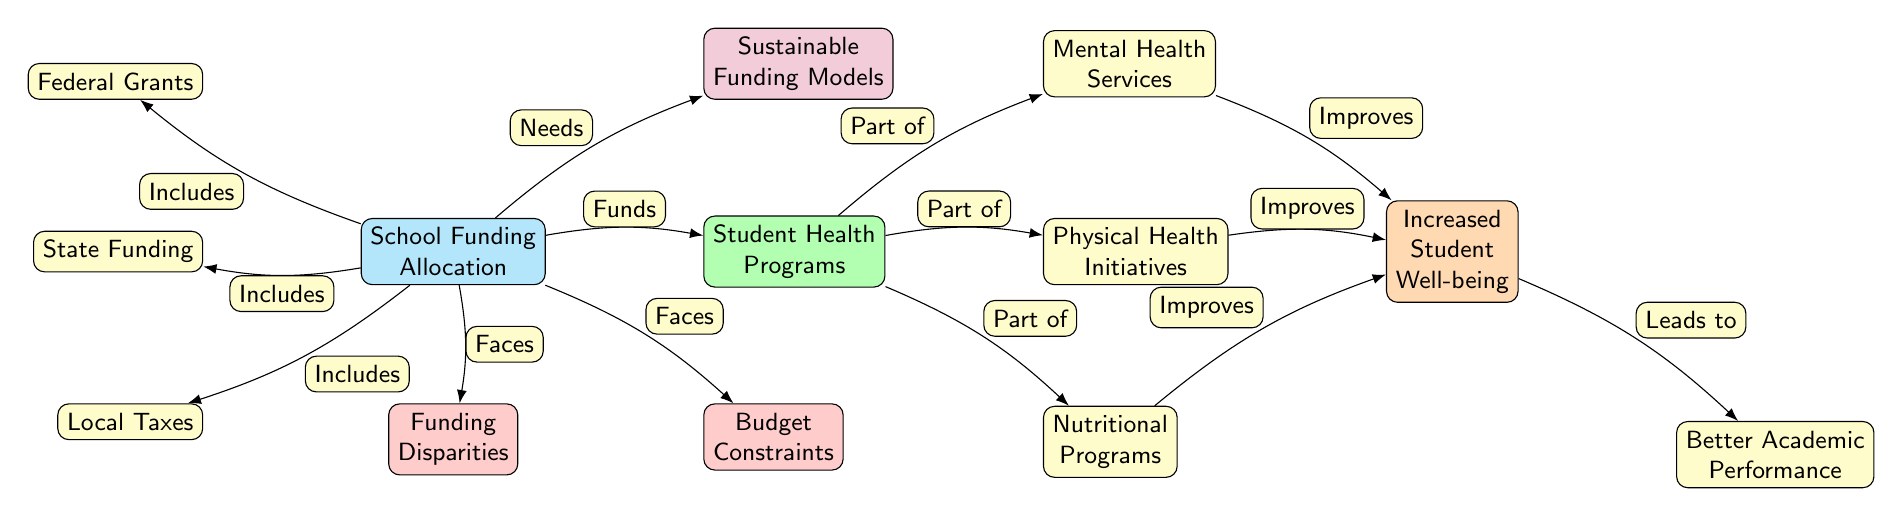What are the three sources of school funding allocation? The diagram lists three sources: Federal Grants, State Funding, and Local Taxes. These nodes are directly connected to the central node for School Funding Allocation, indicating that they are included in the funding allocation process.
Answer: Federal Grants, State Funding, Local Taxes What do student health programs include? The diagram shows that Student Health Programs include Mental Health Services, Physical Health Initiatives, and Nutritional Programs, as they are directly connected to the Student Health Programs node with a "Part of" label.
Answer: Mental Health Services, Physical Health Initiatives, Nutritional Programs What is one benefit of student health programs? The diagram indicates that one benefit is Increased Student Well-being, which is shown as a result of improvements from the different student health initiatives.
Answer: Increased Student Well-being What challenges does school funding allocation face? The diagram indicates that Funding Disparities and Budget Constraints are challenges faced by school funding allocation, as they are connected to the School Funding Allocation node with a "Faces" label.
Answer: Funding Disparities, Budget Constraints How many distinct health programs are listed in the diagram? There are three distinct health programs listed: Mental Health Services, Physical Health Initiatives, and Nutritional Programs, which can be counted as they are represented as nodes connected to Student Health Programs.
Answer: 3 What does increased student well-being lead to? According to the diagram, Increased Student Well-being leads to Better Academic Performance, as indicated by the directional "Leads to" connection between these two nodes.
Answer: Better Academic Performance What needs to be considered for sustainable funding models? The diagram states that sustainable funding models are a necessity indicated by the connection labeled “Needs” from School Funding Allocation, emphasizing the importance of stable funding structures to support health programs.
Answer: Sustainable Funding Models Which type of funding is not included in the diagram? The diagram does not include Private Funding as one of the sources for school funding allocation; the three types mentioned are Federal Grants, State Funding, and Local Taxes.
Answer: Private Funding 